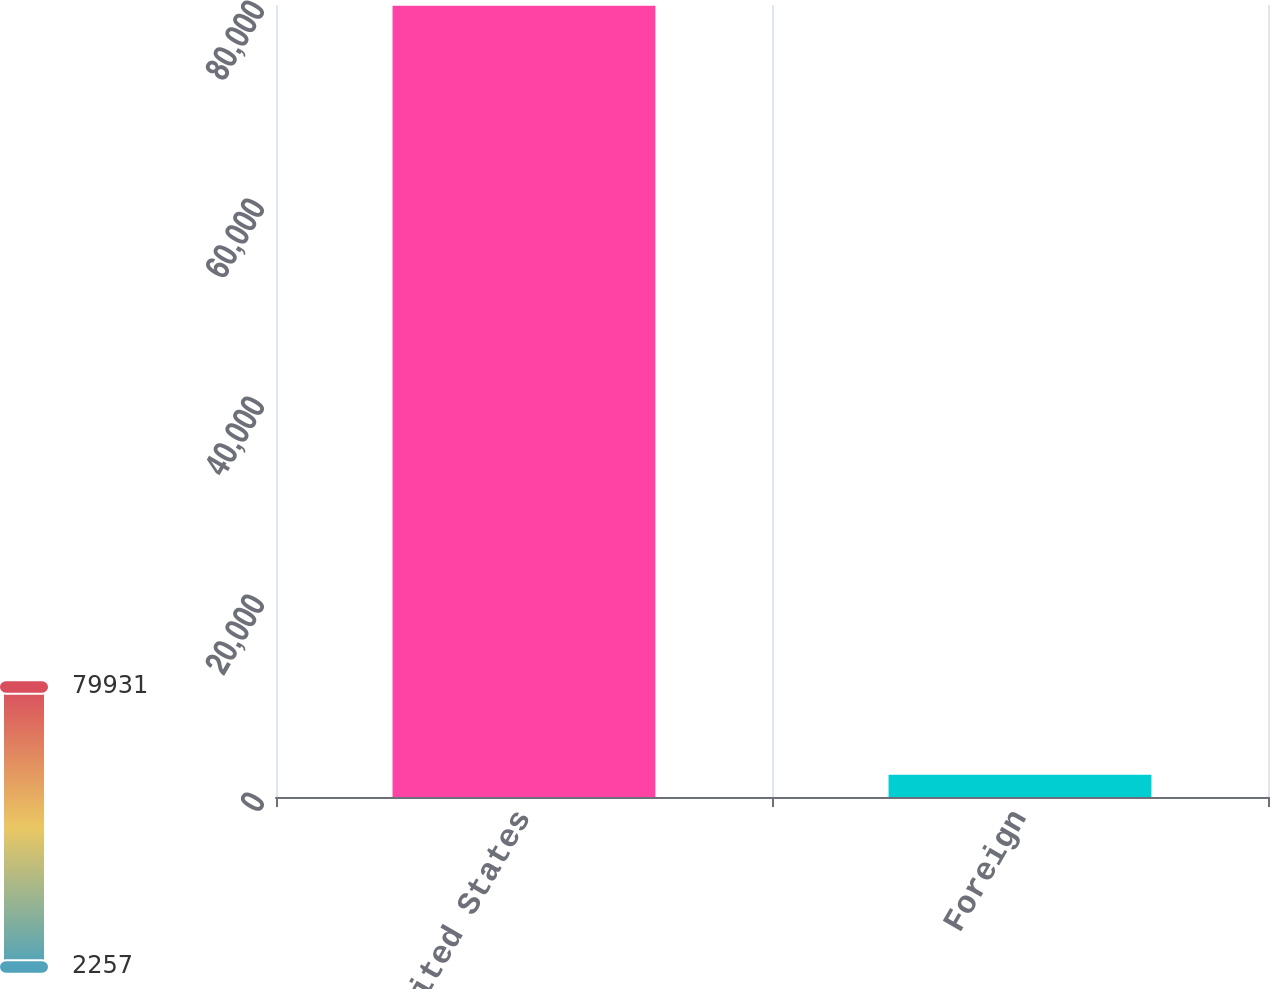<chart> <loc_0><loc_0><loc_500><loc_500><bar_chart><fcel>United States<fcel>Foreign<nl><fcel>79931<fcel>2257<nl></chart> 